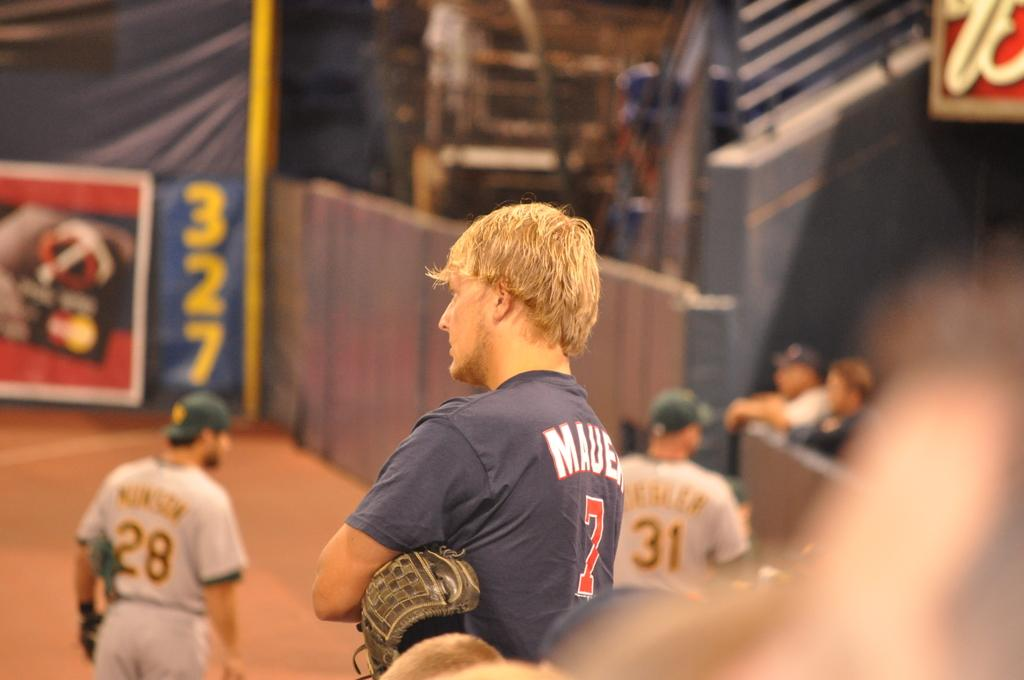Provide a one-sentence caption for the provided image. A man wearing a blue number 7 T-shirt folds his arms and looks on. 